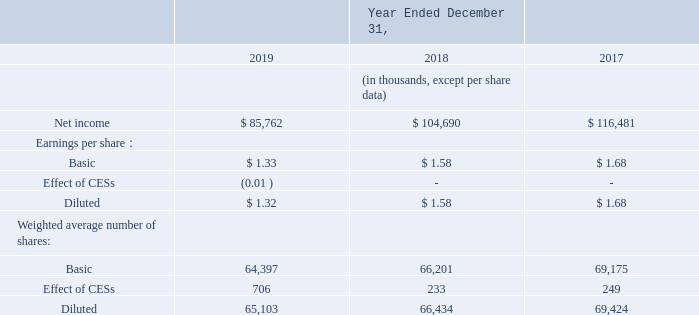Basic and Diluted Net Income Per Share
Basic net income per share is computed using net income divided by the weighted average number of shares of common stock
outstanding (“Weighted Shares”) for the period presented.
Diluted net income per share is computed using net income divided by Weighted Shares and the treasury stock method effect of common equivalent shares (“CESs”) outstanding for each period presented. In the following table, we present a reconciliation of earnings per share and the shares used in the computation of earnings per share for the years ended December 31, 2019, 2018 and 2017 (in thousands, except per share data):
common equivalent shares (“CESs”) outstanding for each period presented. In the following table, we present a reconciliation of
earnings per share and the shares used in the computation of earnings per share for the years ended December 31, 2019, 2018 and
2017 (in thousands, except per share data):
The number of anti-dilutive CESs in 2019, 2018 and 2017 was immaterial. See Note 2 for further information on those securities.
What is the net income of 2019?
Answer scale should be: thousand. 85,762. What is the basic number of shares in 2017? 69,175. What is the diluted earning per share for 2018? 1.58. What is change for basic earning per share between 2019 and 2018? 1.58-1.33
Answer: 0.25. What is the change in number of basic shares between 2017 and 2018? 69,175-66,201
Answer: 2974. What is the change in net income between 2019 and 2018? 104,690-85,762
Answer: 18928. 